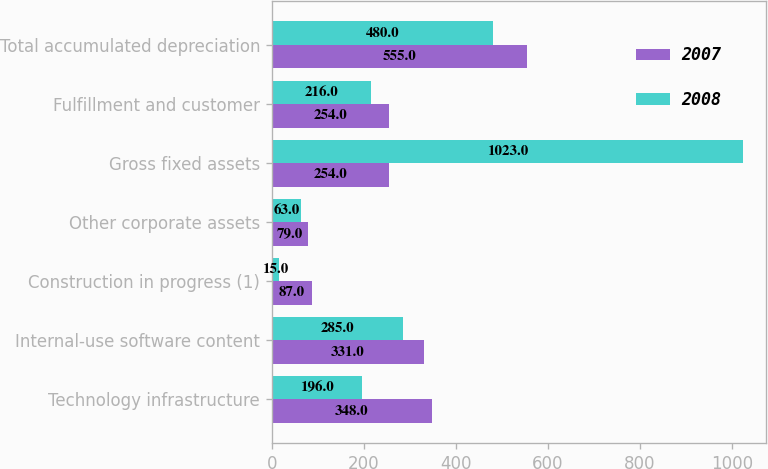Convert chart to OTSL. <chart><loc_0><loc_0><loc_500><loc_500><stacked_bar_chart><ecel><fcel>Technology infrastructure<fcel>Internal-use software content<fcel>Construction in progress (1)<fcel>Other corporate assets<fcel>Gross fixed assets<fcel>Fulfillment and customer<fcel>Total accumulated depreciation<nl><fcel>2007<fcel>348<fcel>331<fcel>87<fcel>79<fcel>254<fcel>254<fcel>555<nl><fcel>2008<fcel>196<fcel>285<fcel>15<fcel>63<fcel>1023<fcel>216<fcel>480<nl></chart> 